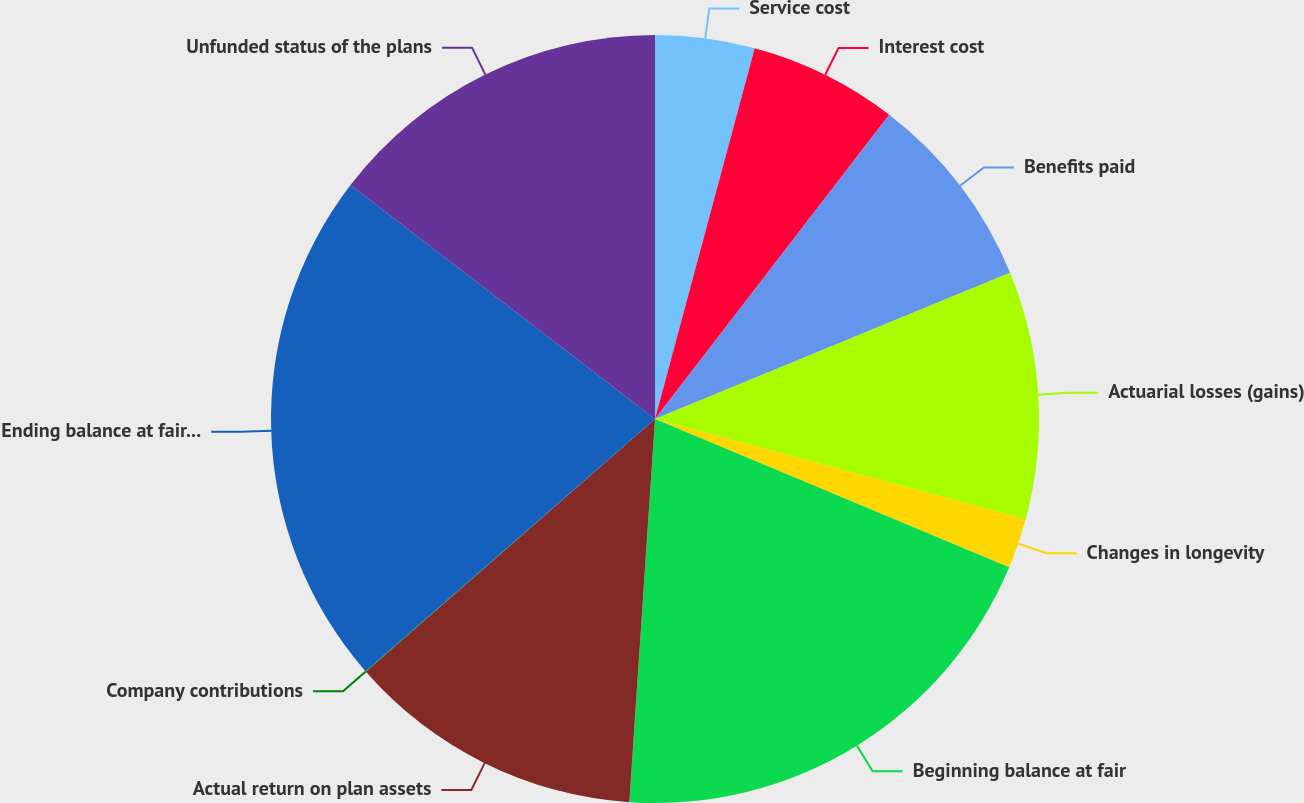<chart> <loc_0><loc_0><loc_500><loc_500><pie_chart><fcel>Service cost<fcel>Interest cost<fcel>Benefits paid<fcel>Actuarial losses (gains)<fcel>Changes in longevity<fcel>Beginning balance at fair<fcel>Actual return on plan assets<fcel>Company contributions<fcel>Ending balance at fair value<fcel>Unfunded status of the plans<nl><fcel>4.18%<fcel>6.26%<fcel>8.34%<fcel>10.42%<fcel>2.11%<fcel>19.75%<fcel>12.5%<fcel>0.03%<fcel>21.83%<fcel>14.57%<nl></chart> 